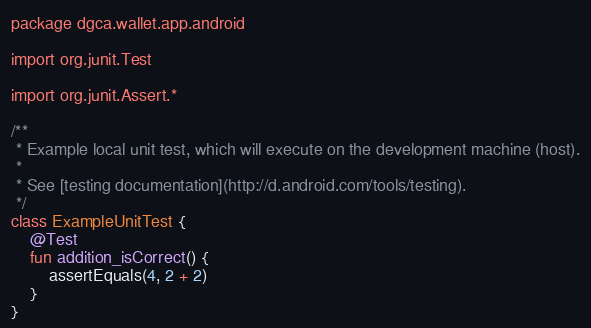Convert code to text. <code><loc_0><loc_0><loc_500><loc_500><_Kotlin_>package dgca.wallet.app.android

import org.junit.Test

import org.junit.Assert.*

/**
 * Example local unit test, which will execute on the development machine (host).
 *
 * See [testing documentation](http://d.android.com/tools/testing).
 */
class ExampleUnitTest {
    @Test
    fun addition_isCorrect() {
        assertEquals(4, 2 + 2)
    }
}</code> 